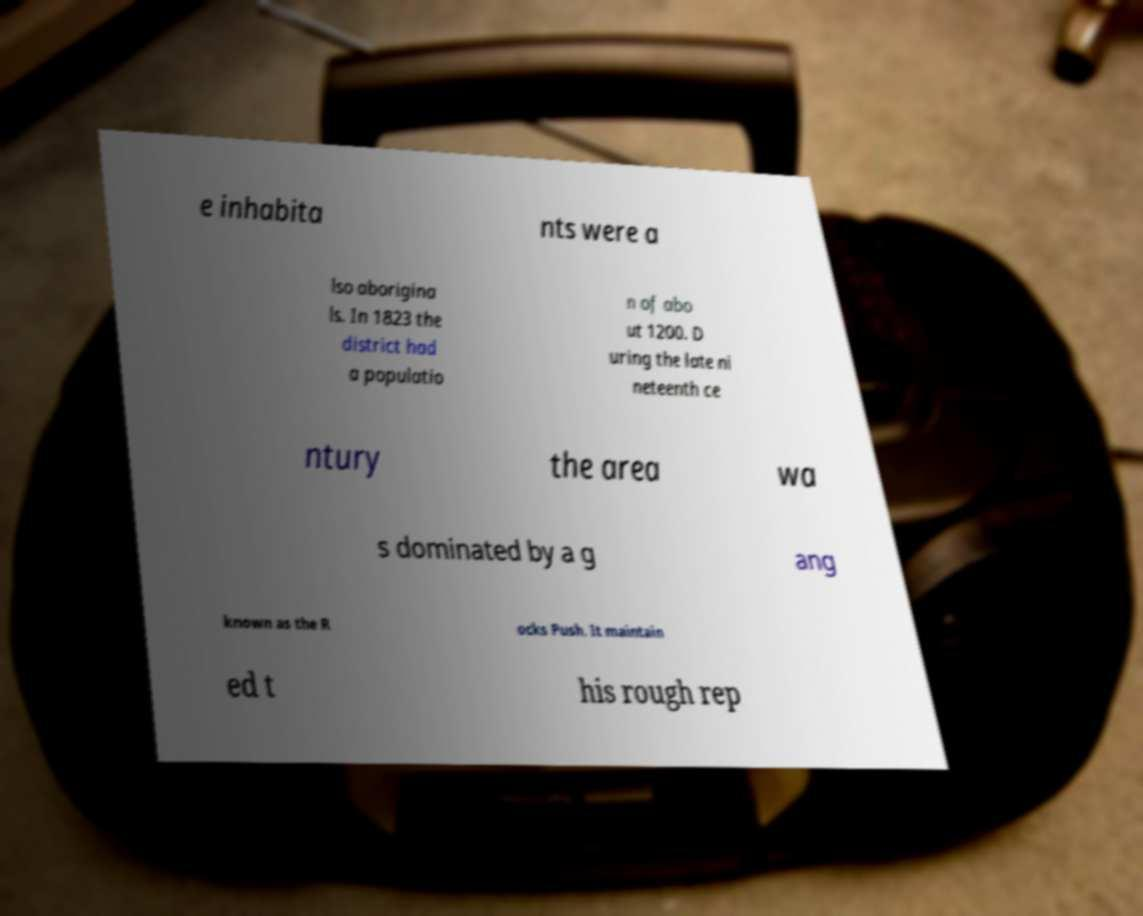Could you assist in decoding the text presented in this image and type it out clearly? e inhabita nts were a lso aborigina ls. In 1823 the district had a populatio n of abo ut 1200. D uring the late ni neteenth ce ntury the area wa s dominated by a g ang known as the R ocks Push. It maintain ed t his rough rep 